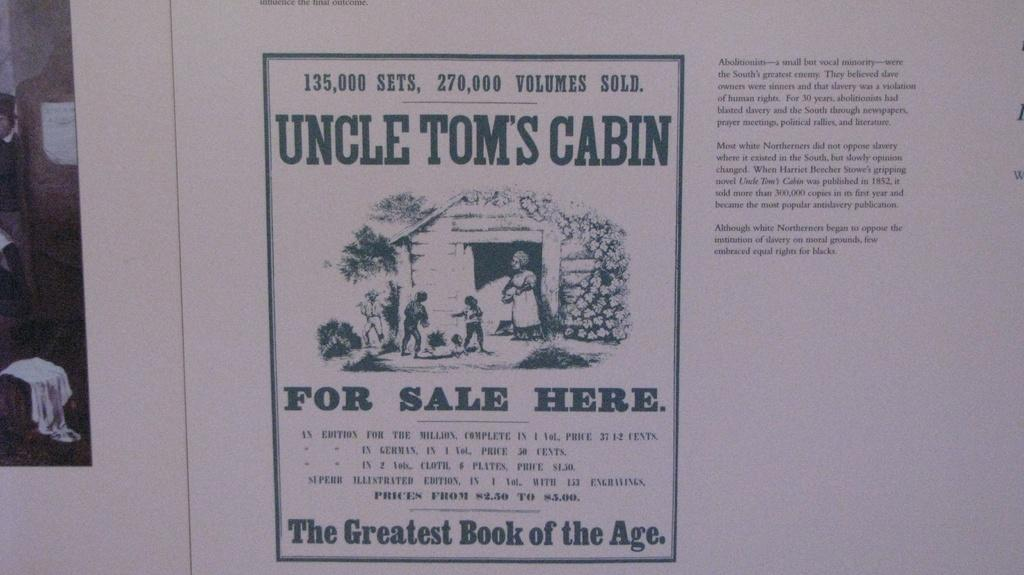<image>
Offer a succinct explanation of the picture presented. Photocopy of a vintage advertisment of Uncle Tom's Cabin for sale . 